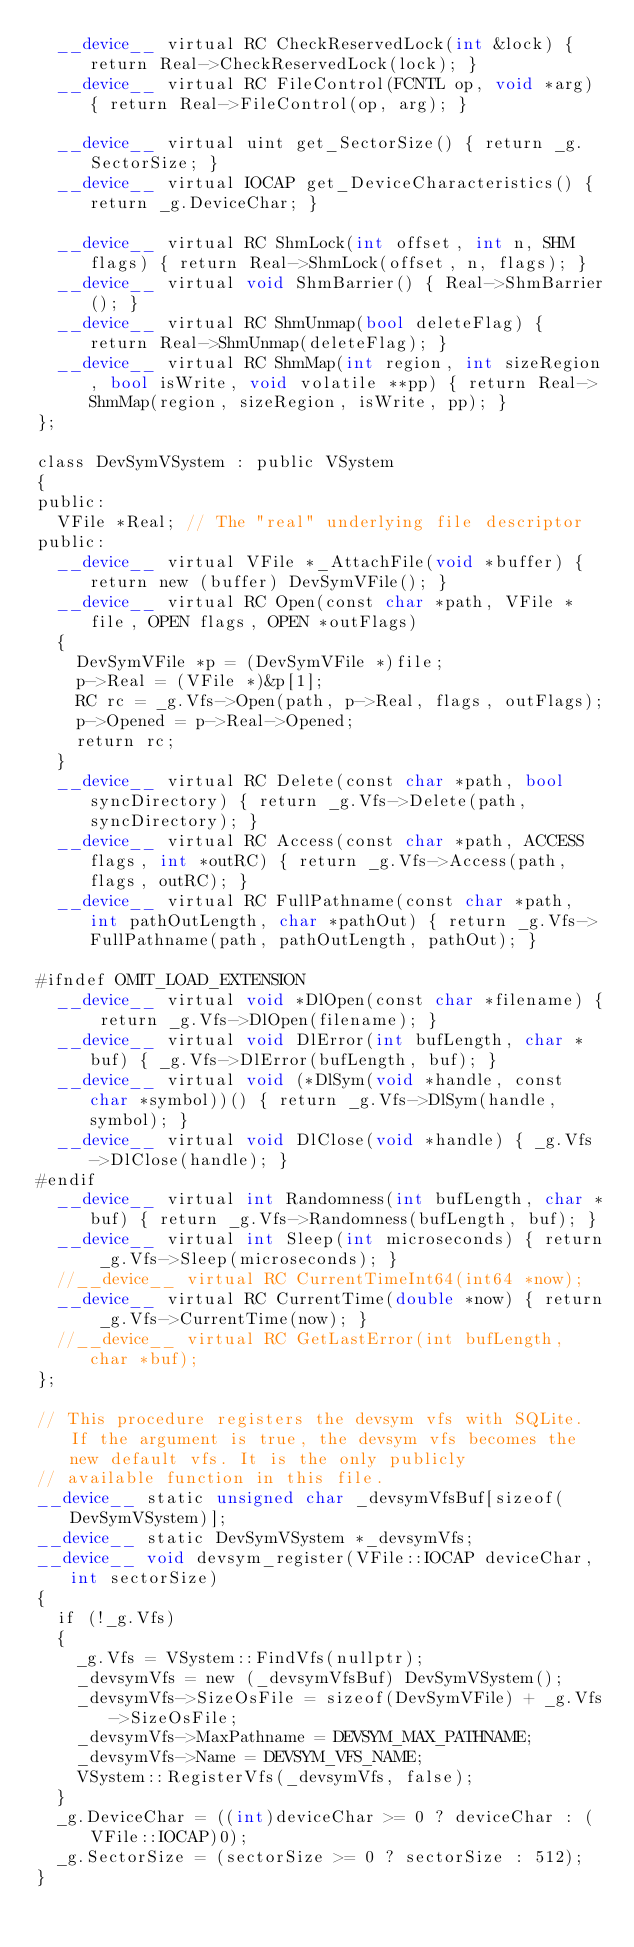Convert code to text. <code><loc_0><loc_0><loc_500><loc_500><_Cuda_>	__device__ virtual RC CheckReservedLock(int &lock) { return Real->CheckReservedLock(lock); }
	__device__ virtual RC FileControl(FCNTL op, void *arg) { return Real->FileControl(op, arg); }

	__device__ virtual uint get_SectorSize() { return _g.SectorSize; }
	__device__ virtual IOCAP get_DeviceCharacteristics() { return _g.DeviceChar; }

	__device__ virtual RC ShmLock(int offset, int n, SHM flags) { return Real->ShmLock(offset, n, flags); }
	__device__ virtual void ShmBarrier() { Real->ShmBarrier(); }
	__device__ virtual RC ShmUnmap(bool deleteFlag) { return Real->ShmUnmap(deleteFlag); }
	__device__ virtual RC ShmMap(int region, int sizeRegion, bool isWrite, void volatile **pp) { return Real->ShmMap(region, sizeRegion, isWrite, pp); }
};

class DevSymVSystem : public VSystem
{
public:
	VFile *Real; // The "real" underlying file descriptor
public:
	__device__ virtual VFile *_AttachFile(void *buffer) { return new (buffer) DevSymVFile(); }
	__device__ virtual RC Open(const char *path, VFile *file, OPEN flags, OPEN *outFlags)
	{
		DevSymVFile *p = (DevSymVFile *)file;
		p->Real = (VFile *)&p[1];
		RC rc = _g.Vfs->Open(path, p->Real, flags, outFlags);
		p->Opened = p->Real->Opened;
		return rc;
	}
	__device__ virtual RC Delete(const char *path, bool syncDirectory) { return _g.Vfs->Delete(path, syncDirectory); }
	__device__ virtual RC Access(const char *path, ACCESS flags, int *outRC) { return _g.Vfs->Access(path, flags, outRC); }
	__device__ virtual RC FullPathname(const char *path, int pathOutLength, char *pathOut) { return _g.Vfs->FullPathname(path, pathOutLength, pathOut); }

#ifndef OMIT_LOAD_EXTENSION
	__device__ virtual void *DlOpen(const char *filename) { return _g.Vfs->DlOpen(filename); }
	__device__ virtual void DlError(int bufLength, char *buf) { _g.Vfs->DlError(bufLength, buf); }
	__device__ virtual void (*DlSym(void *handle, const char *symbol))() { return _g.Vfs->DlSym(handle, symbol); }
	__device__ virtual void DlClose(void *handle) { _g.Vfs->DlClose(handle); }
#endif
	__device__ virtual int Randomness(int bufLength, char *buf) { return _g.Vfs->Randomness(bufLength, buf); }
	__device__ virtual int Sleep(int microseconds) { return _g.Vfs->Sleep(microseconds); }
	//__device__ virtual RC CurrentTimeInt64(int64 *now);
	__device__ virtual RC CurrentTime(double *now) { return _g.Vfs->CurrentTime(now); }
	//__device__ virtual RC GetLastError(int bufLength, char *buf);
};

// This procedure registers the devsym vfs with SQLite. If the argument is true, the devsym vfs becomes the new default vfs. It is the only publicly
// available function in this file.
__device__ static unsigned char _devsymVfsBuf[sizeof(DevSymVSystem)];
__device__ static DevSymVSystem *_devsymVfs;
__device__ void devsym_register(VFile::IOCAP deviceChar, int sectorSize)
{
	if (!_g.Vfs)
	{
		_g.Vfs = VSystem::FindVfs(nullptr);
		_devsymVfs = new (_devsymVfsBuf) DevSymVSystem();
		_devsymVfs->SizeOsFile = sizeof(DevSymVFile) + _g.Vfs->SizeOsFile;
		_devsymVfs->MaxPathname = DEVSYM_MAX_PATHNAME;
		_devsymVfs->Name = DEVSYM_VFS_NAME;
		VSystem::RegisterVfs(_devsymVfs, false);
	}
	_g.DeviceChar = ((int)deviceChar >= 0 ? deviceChar : (VFile::IOCAP)0);
	_g.SectorSize = (sectorSize >= 0 ? sectorSize : 512);
}
</code> 